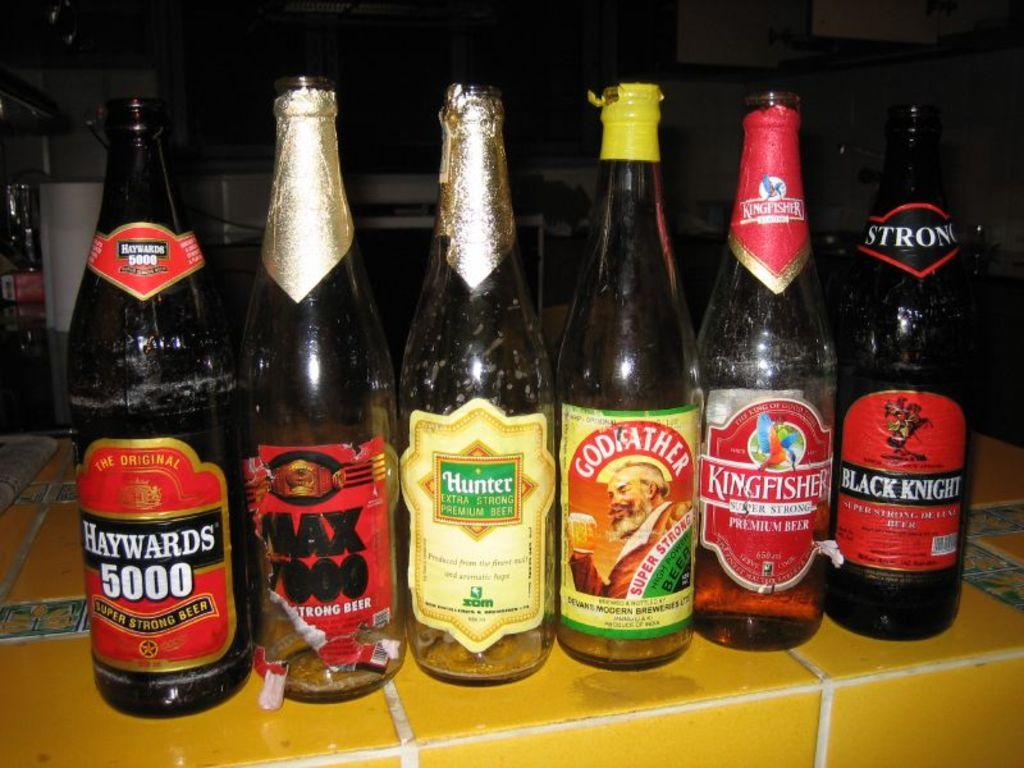Provide a one-sentence caption for the provided image. six bottle of ale, one of which is called Black Knight. 